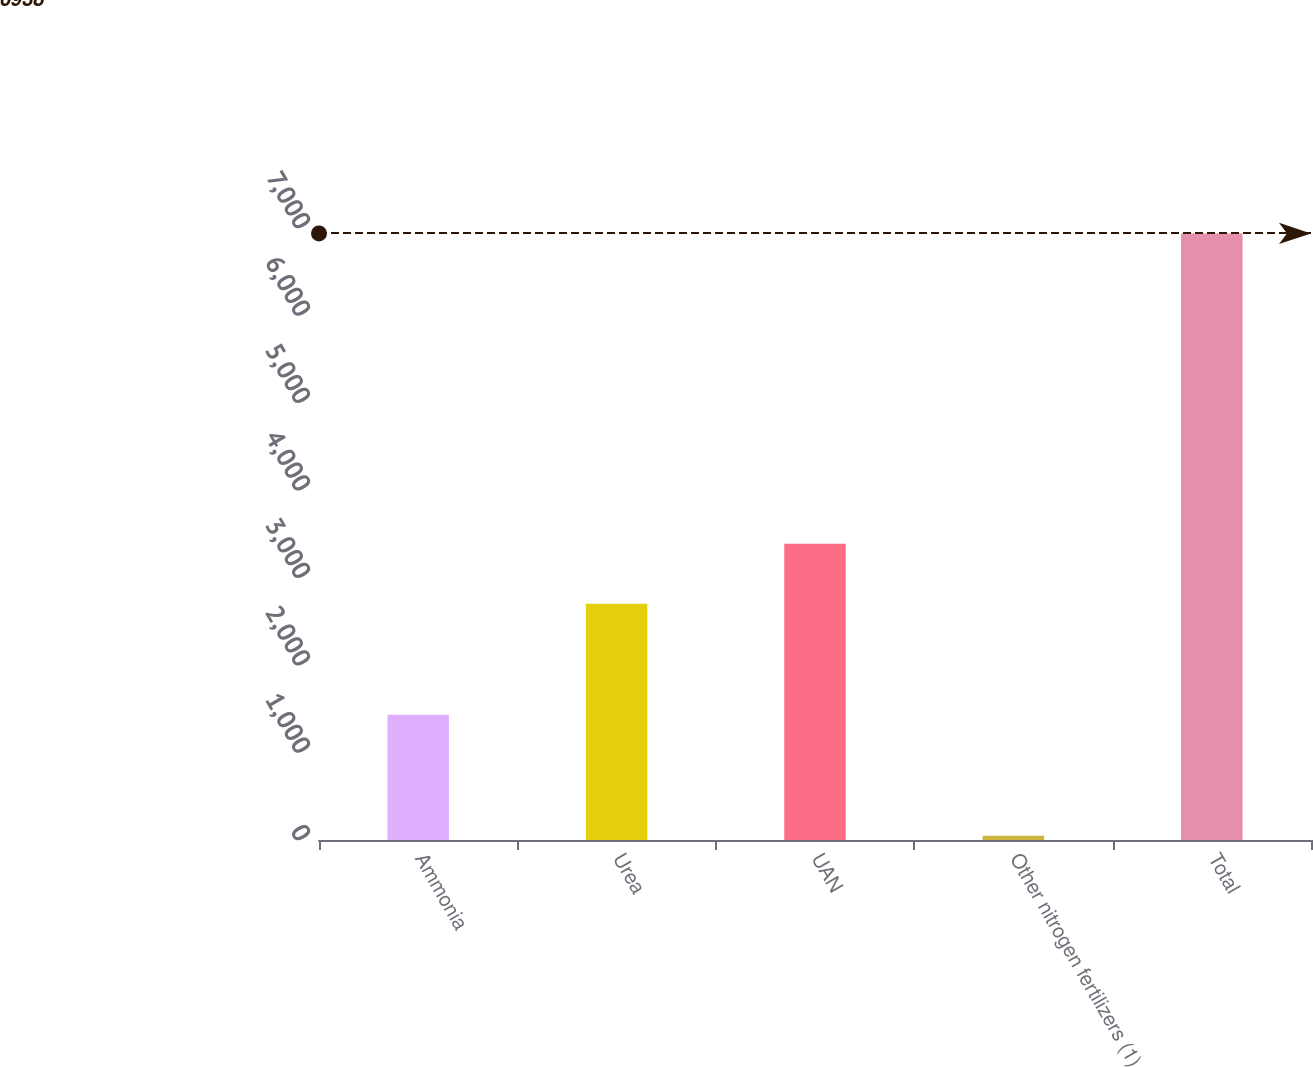<chart> <loc_0><loc_0><loc_500><loc_500><bar_chart><fcel>Ammonia<fcel>Urea<fcel>UAN<fcel>Other nitrogen fertilizers (1)<fcel>Total<nl><fcel>1434<fcel>2701<fcel>3389.9<fcel>49<fcel>6938<nl></chart> 